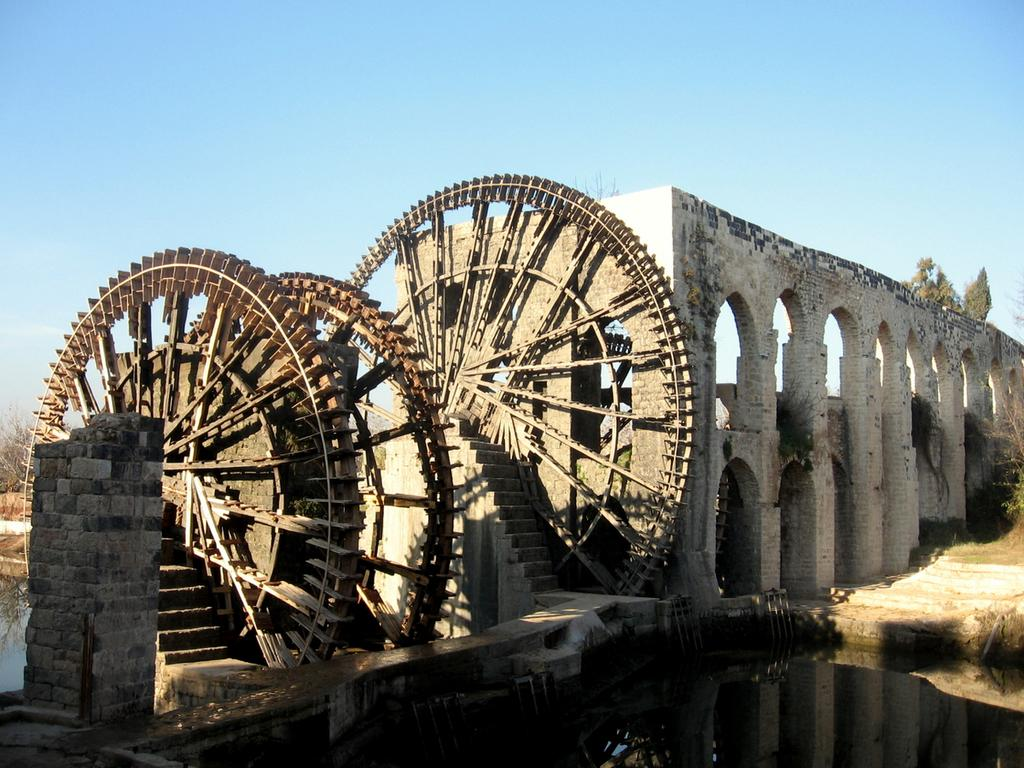What is the main structure in the image? There is a building in the image. What feature can be seen on the building? The building has windows. What unique architectural element is attached to the building? There are large wheels with stairs attached to the building. What can be seen in the background of the image? Trees and the sky are visible in the background of the image. How would you describe the weather based on the sky in the image? The sky appears cloudy in the image. Can you see any deer in the image? There are no deer present in the image. Is there a lift visible in the image? There is no lift visible in the image. 